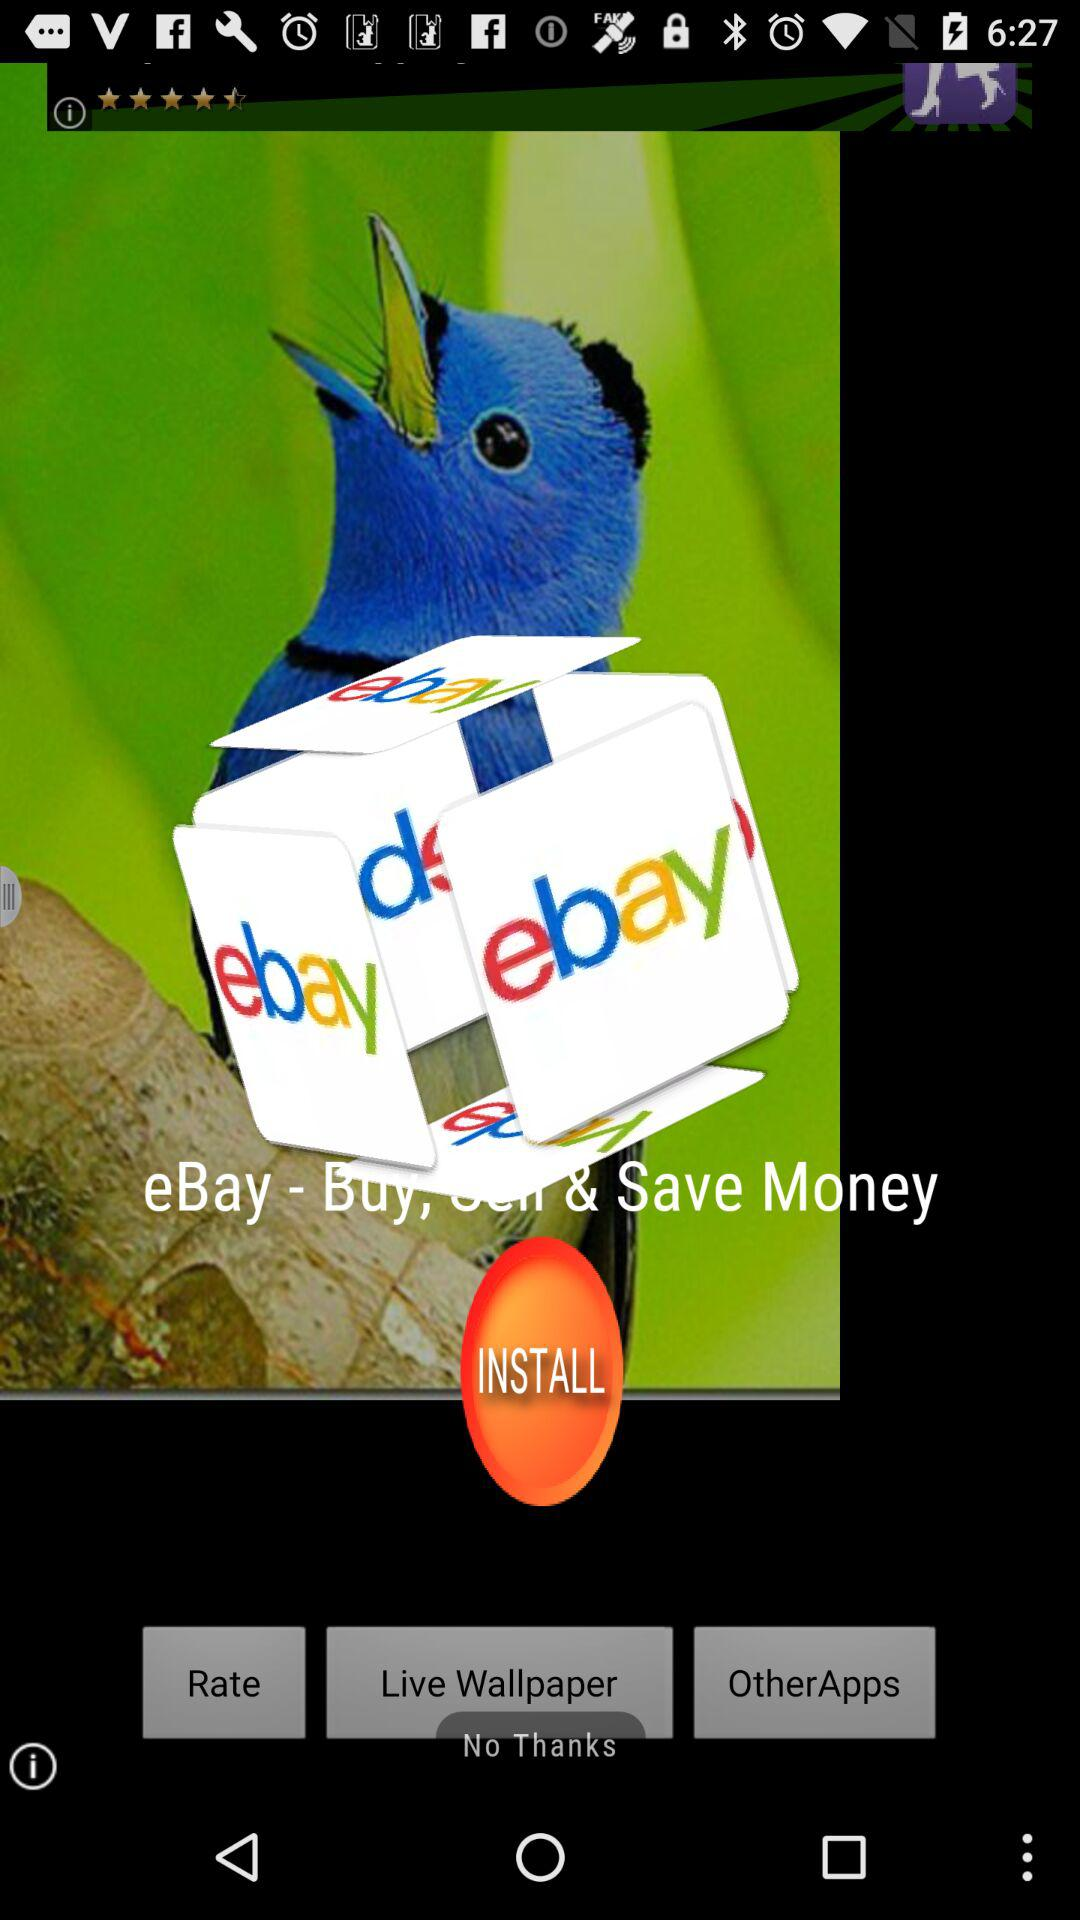What is the name of the application? The name of the application is "eBay". 